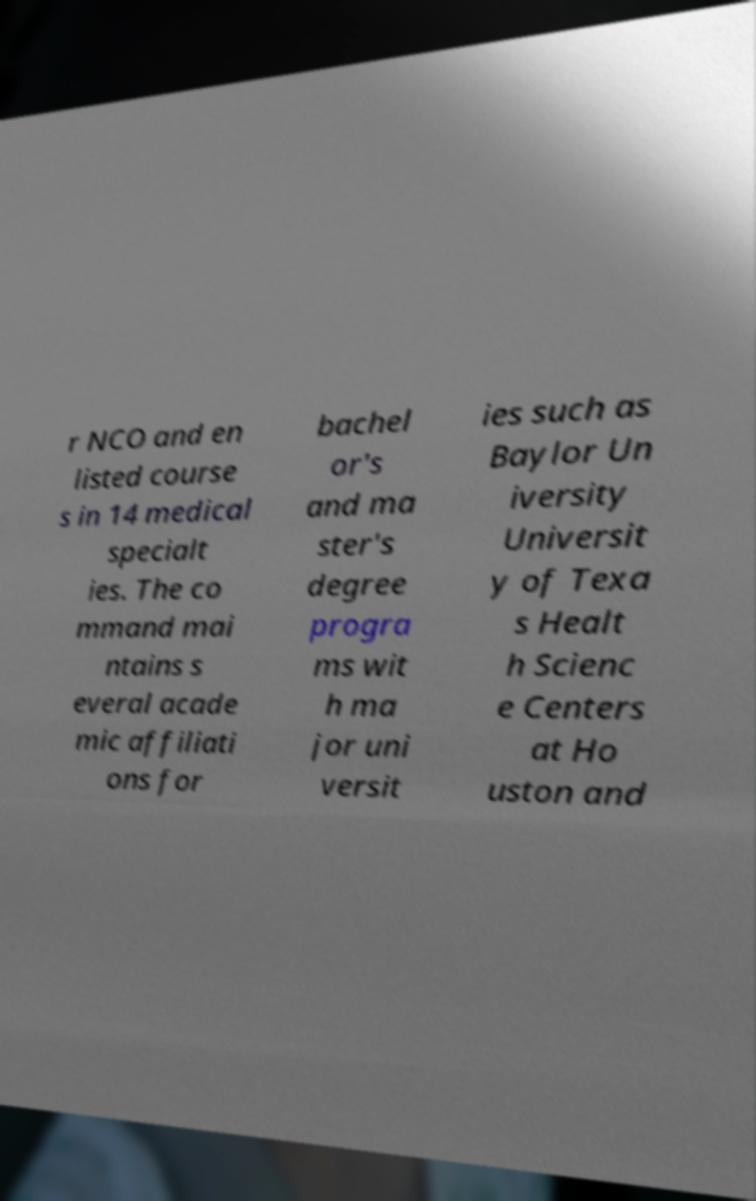For documentation purposes, I need the text within this image transcribed. Could you provide that? r NCO and en listed course s in 14 medical specialt ies. The co mmand mai ntains s everal acade mic affiliati ons for bachel or's and ma ster's degree progra ms wit h ma jor uni versit ies such as Baylor Un iversity Universit y of Texa s Healt h Scienc e Centers at Ho uston and 